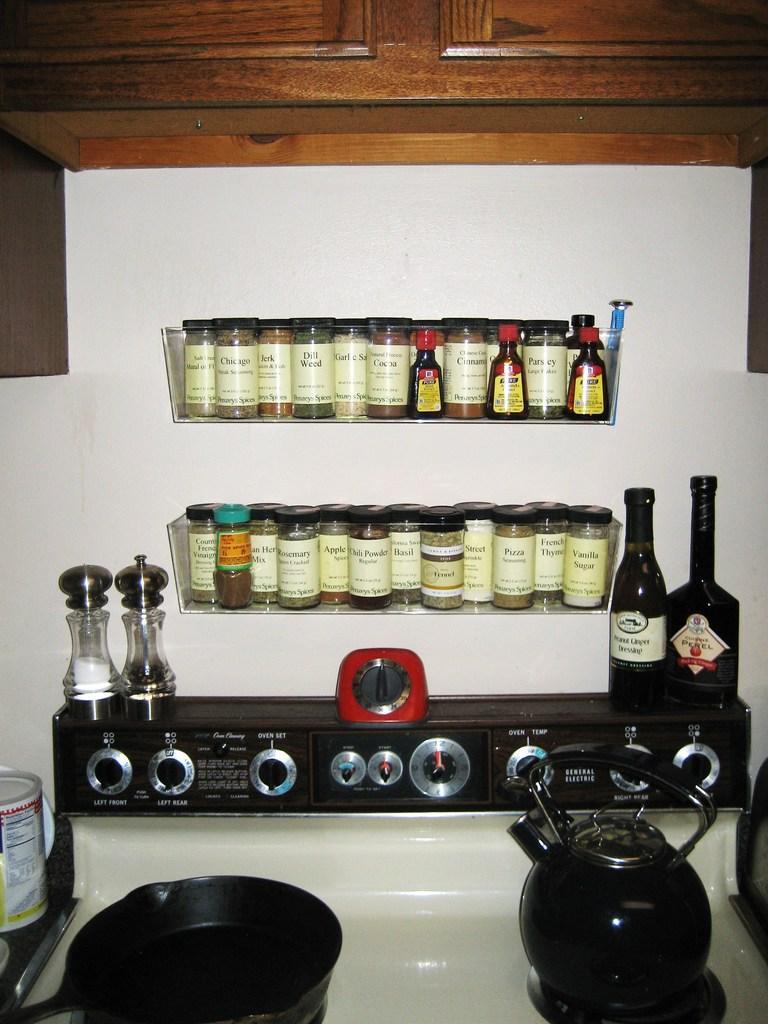Can you describe this image briefly? In this image there are group of glass jars, 3 bottles in a rack fixed to a wall, stove with 2 salt and pepper bottles , another 2 bottles , a pan , a tea pot and a wooden cupboard. 